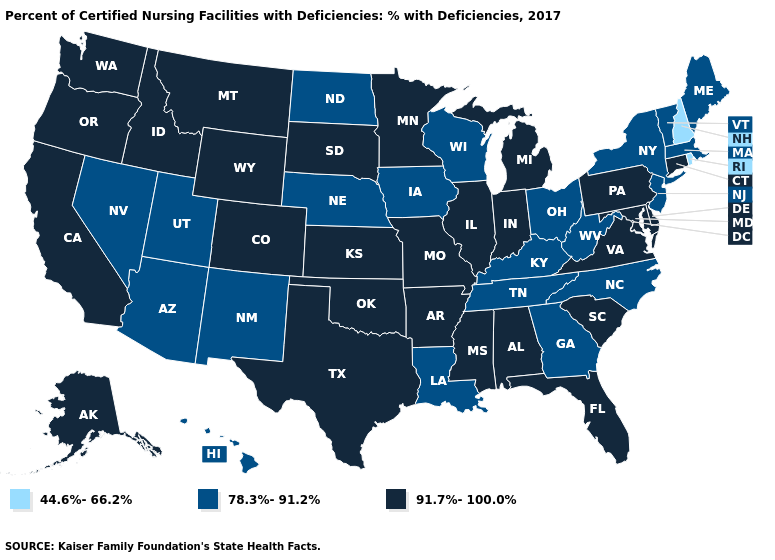What is the value of Kansas?
Give a very brief answer. 91.7%-100.0%. What is the value of California?
Keep it brief. 91.7%-100.0%. Does Massachusetts have the same value as Hawaii?
Write a very short answer. Yes. Does Maryland have the same value as Louisiana?
Give a very brief answer. No. What is the value of Nebraska?
Write a very short answer. 78.3%-91.2%. What is the lowest value in the USA?
Concise answer only. 44.6%-66.2%. What is the highest value in the USA?
Short answer required. 91.7%-100.0%. What is the lowest value in the MidWest?
Be succinct. 78.3%-91.2%. What is the highest value in the USA?
Be succinct. 91.7%-100.0%. What is the highest value in the Northeast ?
Concise answer only. 91.7%-100.0%. Does Tennessee have the lowest value in the South?
Write a very short answer. Yes. Does Washington have a higher value than Indiana?
Short answer required. No. What is the value of Louisiana?
Answer briefly. 78.3%-91.2%. Which states have the lowest value in the USA?
Answer briefly. New Hampshire, Rhode Island. Among the states that border Connecticut , does Massachusetts have the lowest value?
Concise answer only. No. 